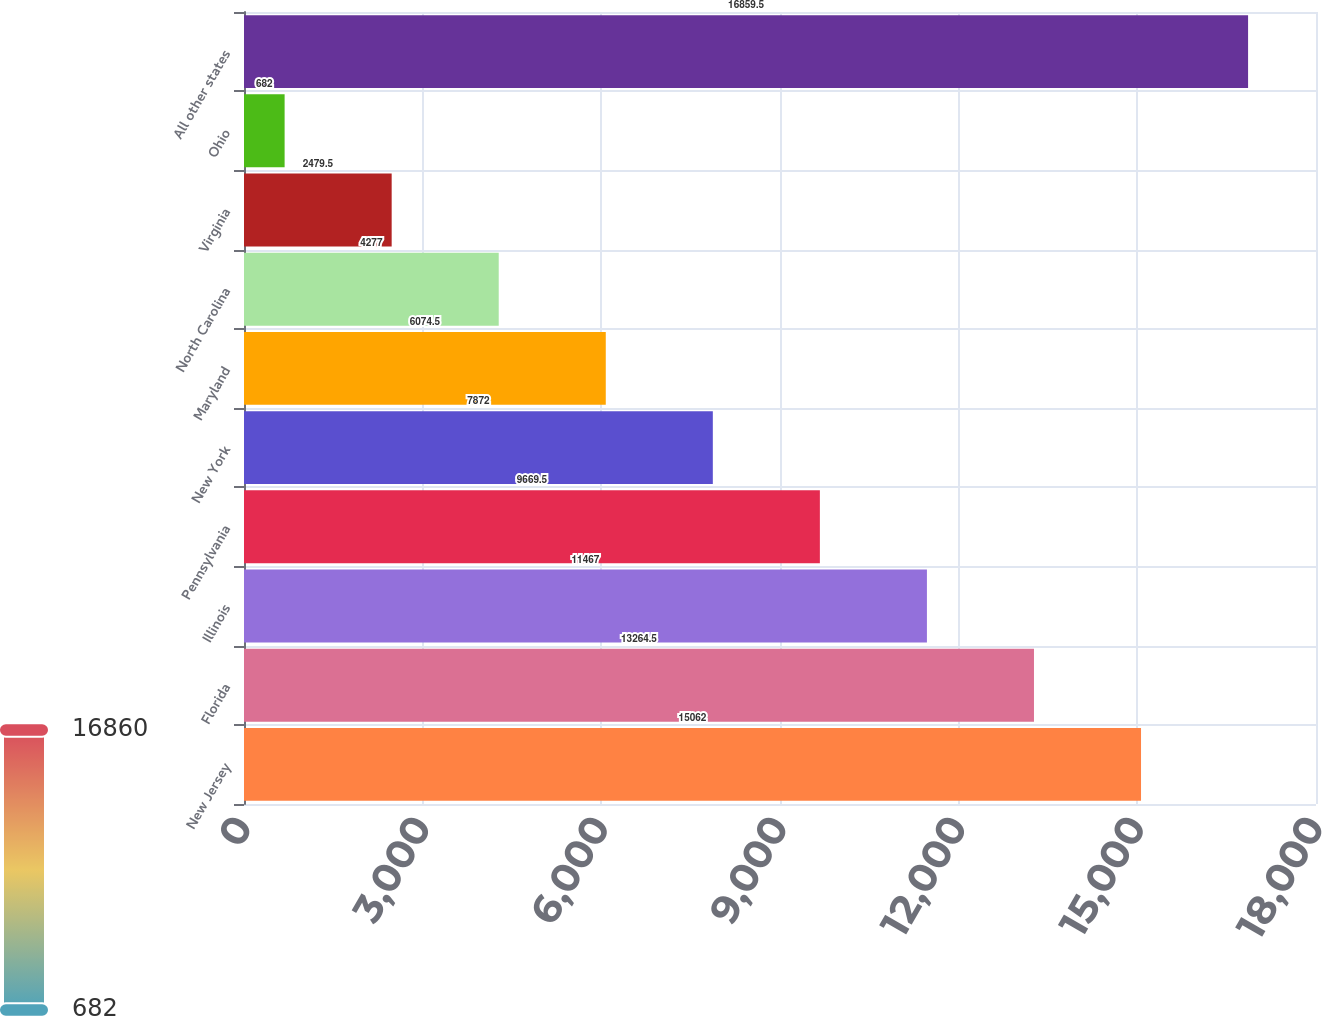Convert chart to OTSL. <chart><loc_0><loc_0><loc_500><loc_500><bar_chart><fcel>New Jersey<fcel>Florida<fcel>Illinois<fcel>Pennsylvania<fcel>New York<fcel>Maryland<fcel>North Carolina<fcel>Virginia<fcel>Ohio<fcel>All other states<nl><fcel>15062<fcel>13264.5<fcel>11467<fcel>9669.5<fcel>7872<fcel>6074.5<fcel>4277<fcel>2479.5<fcel>682<fcel>16859.5<nl></chart> 